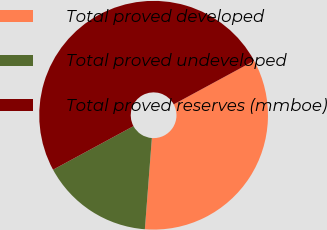<chart> <loc_0><loc_0><loc_500><loc_500><pie_chart><fcel>Total proved developed<fcel>Total proved undeveloped<fcel>Total proved reserves (mmboe)<nl><fcel>34.12%<fcel>15.88%<fcel>50.0%<nl></chart> 